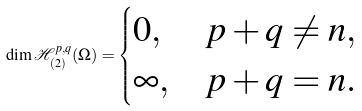<formula> <loc_0><loc_0><loc_500><loc_500>\dim \mathcal { H } _ { ( 2 ) } ^ { p , q } ( \Omega ) = \begin{cases} 0 , & p + q \not = n , \\ \infty , & p + q = n . \end{cases}</formula> 